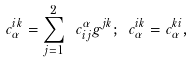Convert formula to latex. <formula><loc_0><loc_0><loc_500><loc_500>c _ { \alpha } ^ { i k } = \sum _ { j = 1 } ^ { 2 } \ c _ { i j } ^ { \alpha } g ^ { j k } ; \text { } c _ { \alpha } ^ { i k } = c _ { \alpha } ^ { k i } ,</formula> 